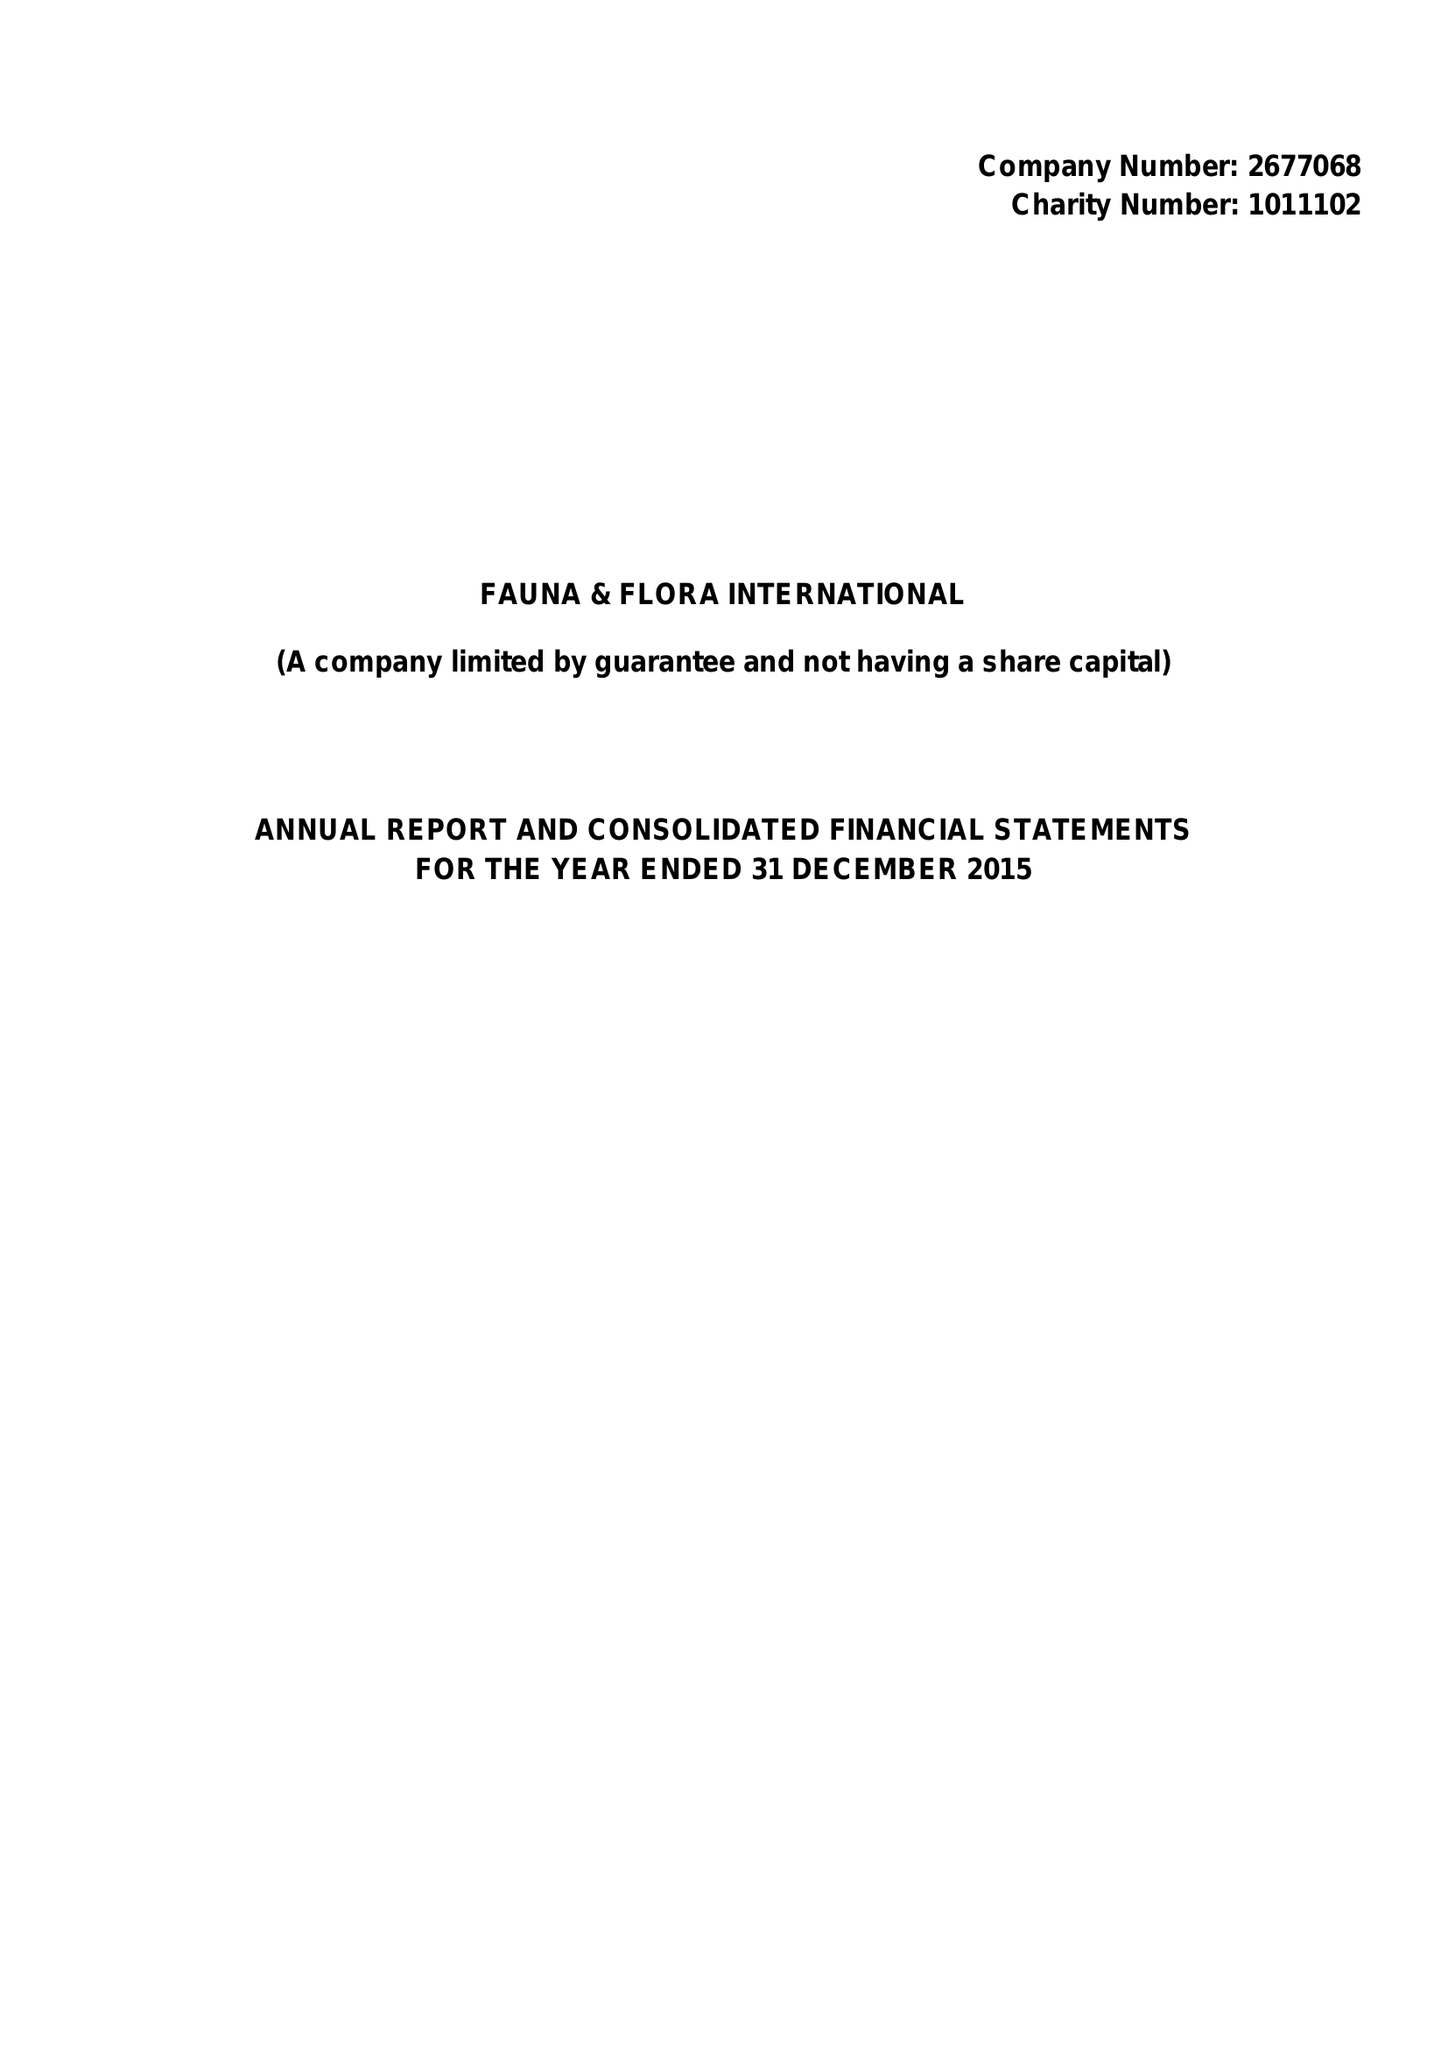What is the value for the income_annually_in_british_pounds?
Answer the question using a single word or phrase. 20729083.00 